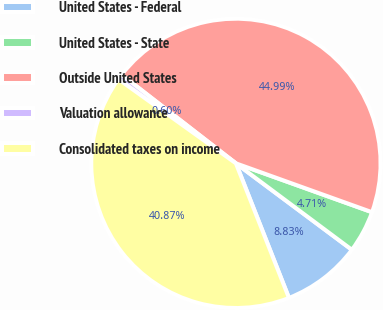Convert chart to OTSL. <chart><loc_0><loc_0><loc_500><loc_500><pie_chart><fcel>United States - Federal<fcel>United States - State<fcel>Outside United States<fcel>Valuation allowance<fcel>Consolidated taxes on income<nl><fcel>8.83%<fcel>4.71%<fcel>44.99%<fcel>0.6%<fcel>40.87%<nl></chart> 